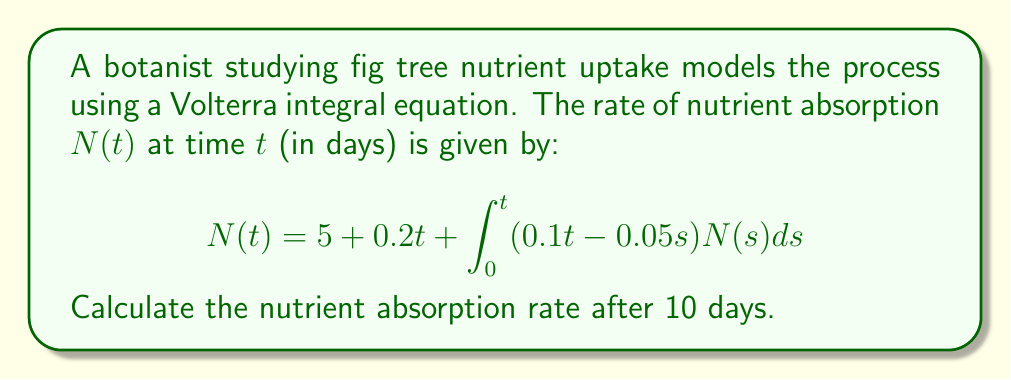Can you answer this question? To solve this Volterra integral equation, we'll use the method of successive approximations:

1) Start with the initial approximation $N_0(t) = 5 + 0.2t$

2) Substitute this into the integral equation to get the next approximation:

   $$N_1(t) = 5 + 0.2t + \int_0^t (0.1t - 0.05s)(5 + 0.2s)ds$$

3) Evaluate the integral:
   $$\begin{align}
   N_1(t) &= 5 + 0.2t + 0.1t\int_0^t (5 + 0.2s)ds - 0.05\int_0^t s(5 + 0.2s)ds \\
   &= 5 + 0.2t + 0.1t(5t + 0.1t^2) - 0.05(2.5t^2 + \frac{1}{15}t^3) \\
   &= 5 + 0.2t + 0.5t^2 + 0.01t^3 - 0.125t^2 - \frac{1}{300}t^3 \\
   &= 5 + 0.2t + 0.375t^2 + \frac{2}{300}t^3
   \end{align}$$

4) For t = 10 days:
   $$N_1(10) = 5 + 0.2(10) + 0.375(100) + \frac{2}{300}(1000) = 45.67$$

5) For higher precision, we could continue this process, but the first approximation is often sufficient for practical purposes.
Answer: 45.67 units/day 